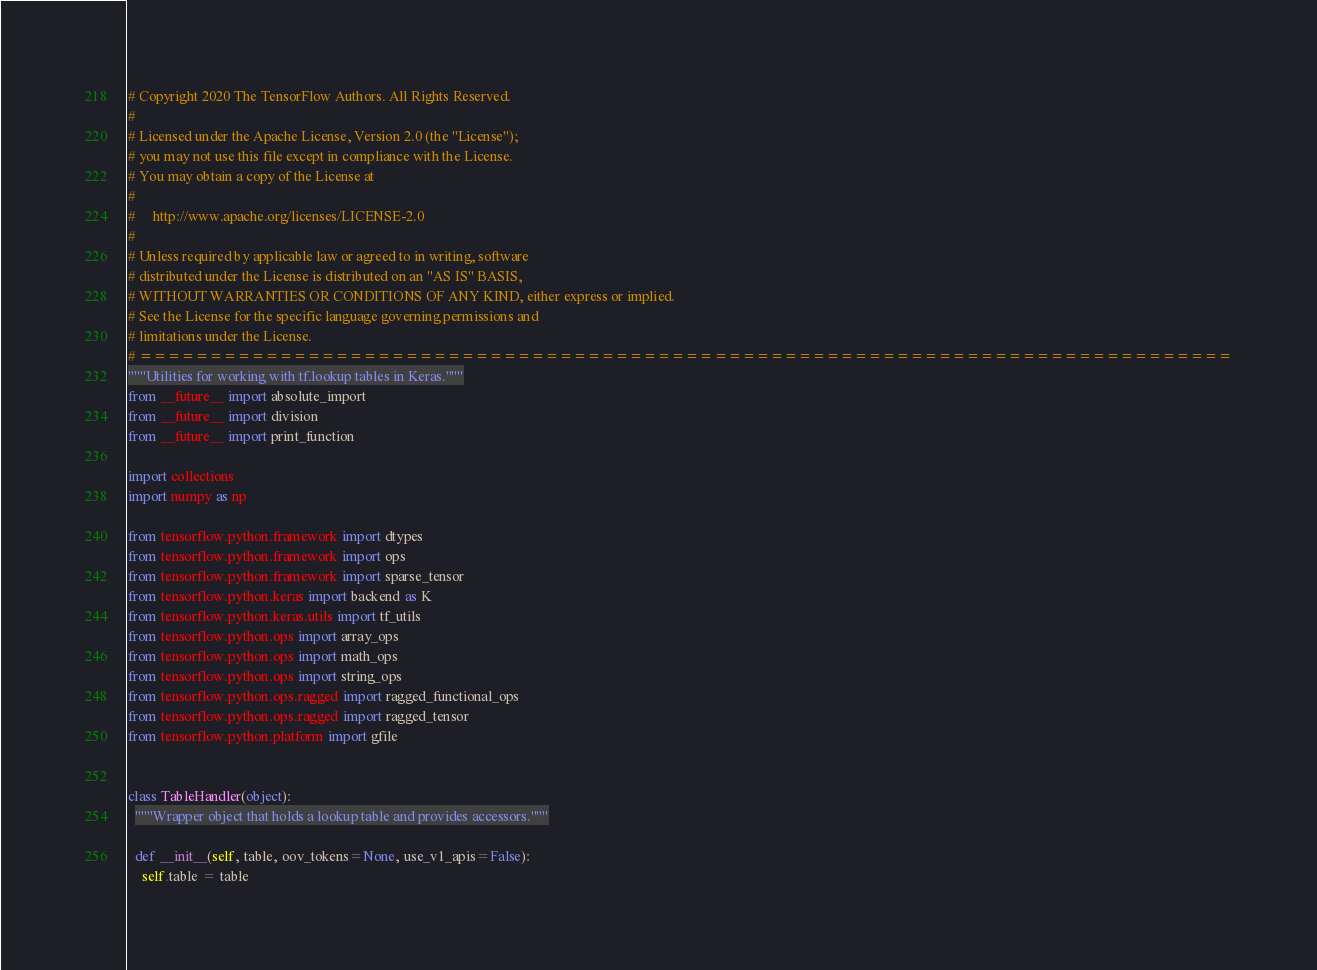Convert code to text. <code><loc_0><loc_0><loc_500><loc_500><_Python_># Copyright 2020 The TensorFlow Authors. All Rights Reserved.
#
# Licensed under the Apache License, Version 2.0 (the "License");
# you may not use this file except in compliance with the License.
# You may obtain a copy of the License at
#
#     http://www.apache.org/licenses/LICENSE-2.0
#
# Unless required by applicable law or agreed to in writing, software
# distributed under the License is distributed on an "AS IS" BASIS,
# WITHOUT WARRANTIES OR CONDITIONS OF ANY KIND, either express or implied.
# See the License for the specific language governing permissions and
# limitations under the License.
# ==============================================================================
"""Utilities for working with tf.lookup tables in Keras."""
from __future__ import absolute_import
from __future__ import division
from __future__ import print_function

import collections
import numpy as np

from tensorflow.python.framework import dtypes
from tensorflow.python.framework import ops
from tensorflow.python.framework import sparse_tensor
from tensorflow.python.keras import backend as K
from tensorflow.python.keras.utils import tf_utils
from tensorflow.python.ops import array_ops
from tensorflow.python.ops import math_ops
from tensorflow.python.ops import string_ops
from tensorflow.python.ops.ragged import ragged_functional_ops
from tensorflow.python.ops.ragged import ragged_tensor
from tensorflow.python.platform import gfile


class TableHandler(object):
  """Wrapper object that holds a lookup table and provides accessors."""

  def __init__(self, table, oov_tokens=None, use_v1_apis=False):
    self.table = table</code> 